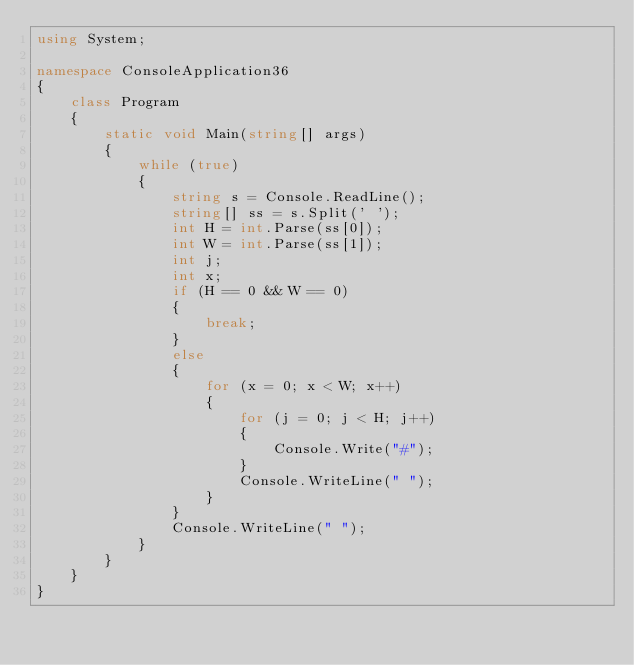Convert code to text. <code><loc_0><loc_0><loc_500><loc_500><_C#_>using System;

namespace ConsoleApplication36
{
    class Program
    {
        static void Main(string[] args)
        {
            while (true)
            {
                string s = Console.ReadLine();
                string[] ss = s.Split(' ');
                int H = int.Parse(ss[0]);
                int W = int.Parse(ss[1]);
                int j;
                int x;
                if (H == 0 && W == 0)
                {
                    break;
                }
                else
                {
                    for (x = 0; x < W; x++)
                    {
                        for (j = 0; j < H; j++)
                        {
                            Console.Write("#");
                        }
                        Console.WriteLine(" ");
                    }
                }
                Console.WriteLine(" ");
            }
        }
    }
}</code> 